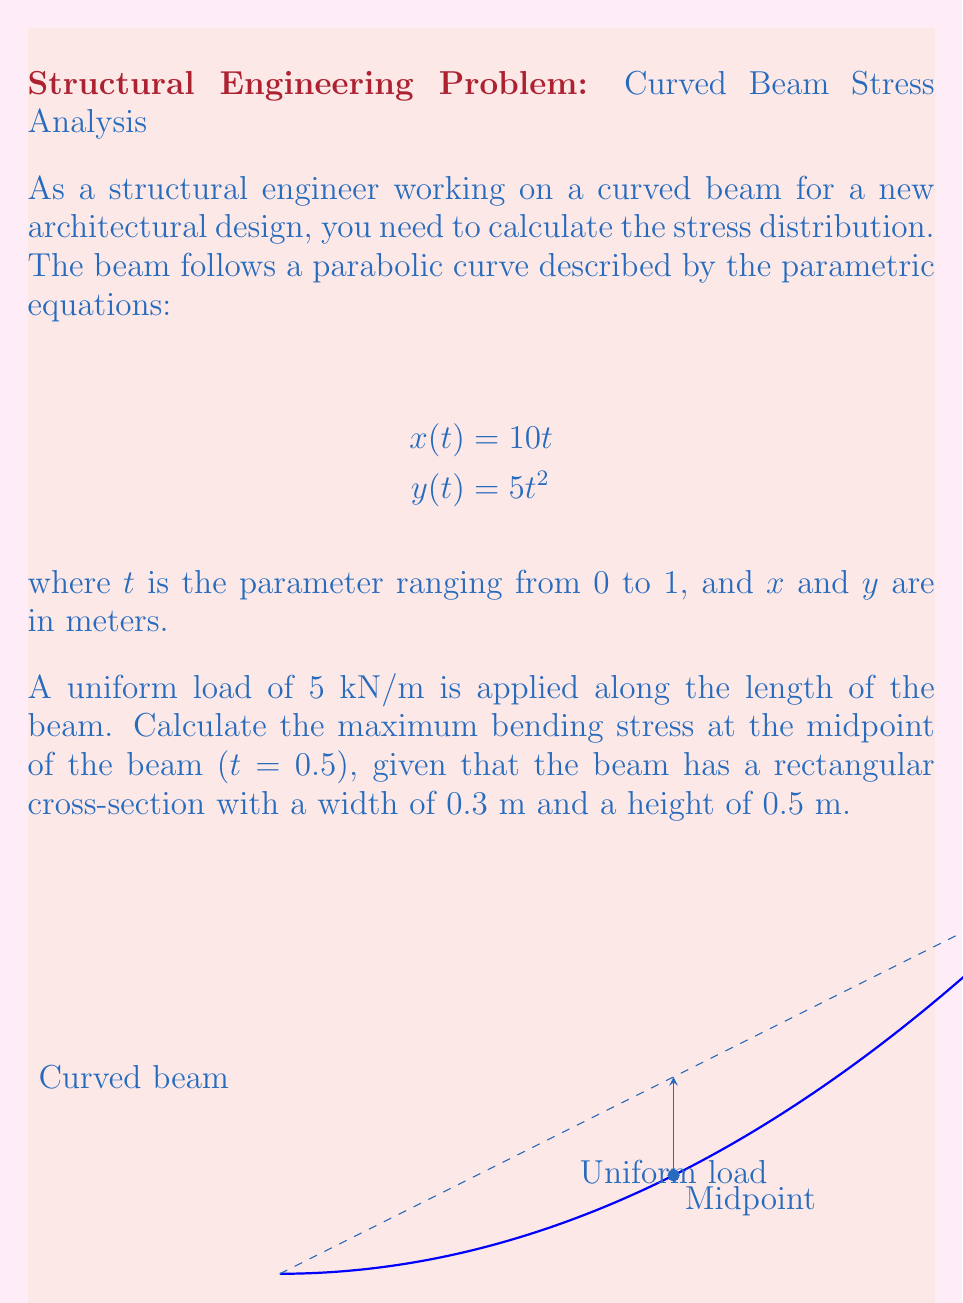Show me your answer to this math problem. To solve this problem, we'll follow these steps:

1) First, we need to calculate the arc length of the beam. The formula for arc length in parametric form is:

   $$L = \int_0^1 \sqrt{\left(\frac{dx}{dt}\right)^2 + \left(\frac{dy}{dt}\right)^2} dt$$

2) We find $\frac{dx}{dt}$ and $\frac{dy}{dt}$:
   
   $$\frac{dx}{dt} = 10$$
   $$\frac{dy}{dt} = 10t$$

3) Substituting into the arc length formula:

   $$L = \int_0^1 \sqrt{10^2 + (10t)^2} dt = 10\int_0^1 \sqrt{1 + t^2} dt$$

4) This integral evaluates to:

   $$L = 10 \left[t\sqrt{1+t^2} + \ln(t + \sqrt{1+t^2})\right]_0^1 \approx 10.9 \text{ m}$$

5) The bending moment at the midpoint $(t = 0.5)$ can be approximated as:

   $$M = \frac{wL^2}{8} = \frac{5 \cdot 10.9^2}{8} \approx 74.3 \text{ kN·m}$$

6) The second moment of area for a rectangular cross-section is:

   $$I = \frac{bh^3}{12} = \frac{0.3 \cdot 0.5^3}{12} = 0.003125 \text{ m}^4$$

7) The maximum bending stress occurs at the outer fibers and is given by:

   $$\sigma_{max} = \frac{My}{I}$$

   where $y$ is half the height of the beam $(0.25 \text{ m})$.

8) Substituting the values:

   $$\sigma_{max} = \frac{74.3 \cdot 0.25}{0.003125} = 5944 \text{ kPa} = 5.944 \text{ MPa}$$
Answer: 5.944 MPa 